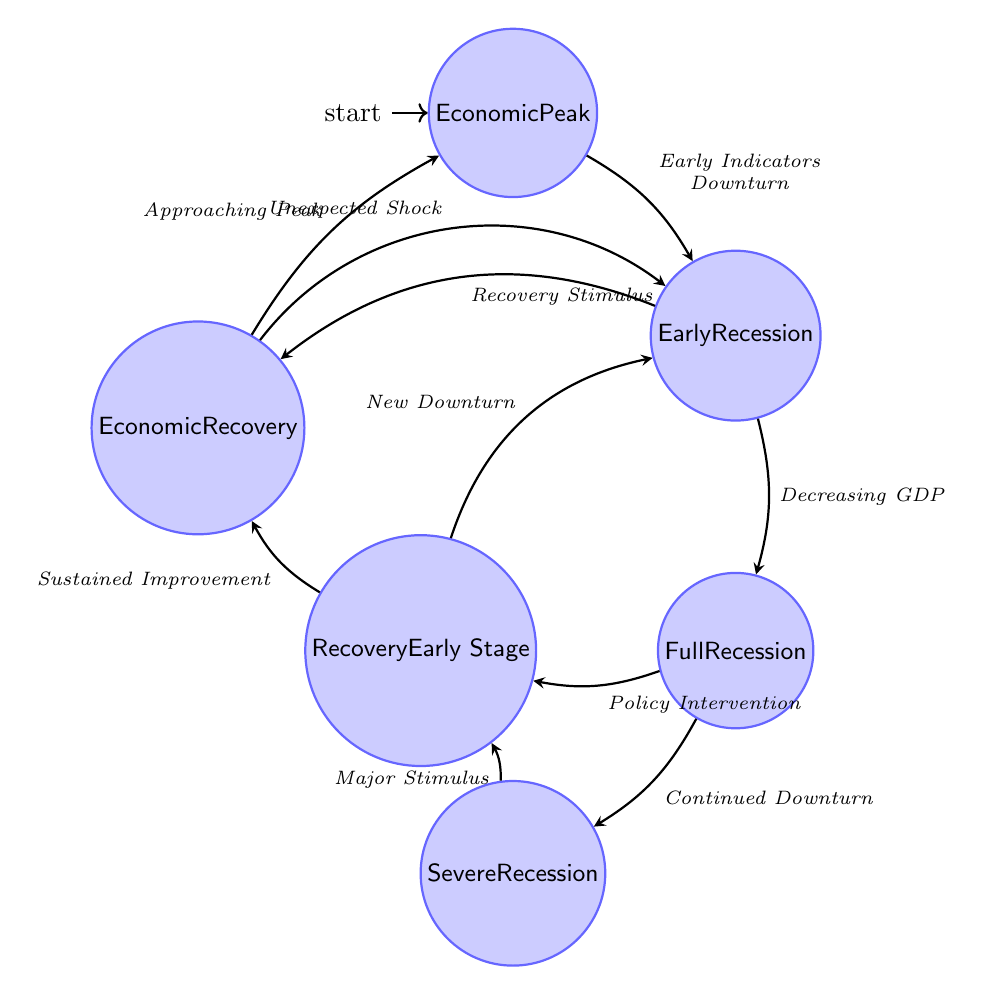What is the initial state of the diagram? The initial state is indicated as the starting point in the diagram, which is marked with an 'initial' symbol. Here, the node labeled "Economic Peak" represents the starting point of the Finite State Machine.
Answer: Economic Peak How many states are in the diagram? To find the total number of states, we count each distinct labeled state node in the diagram. There are six labeled states: Economic Peak, Early Recession, Full Recession, Severe Recession, Recovery Early Stage, and Economic Recovery.
Answer: 6 What transition leads to Severe Recession from Full Recession? The transition from Full Recession to Severe Recession is indicated by an arrow connecting the two states, labeled as "Continued Downturn."
Answer: Continued Downturn What event can transition from Early Recession to Economic Recovery? The event that enables this transition is "Recovery Stimulus," denoting a positive action taken during the Early Recession phase that can lead directly to Economic Recovery.
Answer: Recovery Stimulus In which state does the diagram indicate a possibility of returning to Early Recession? There are two possible transitions to Early Recession. One is from Recovery Early Stage labeled "New Downturn," and the other is from Economic Recovery labeled "Unexpected Shock."
Answer: New Downturn and Unexpected Shock Which state indicates a sustained period of negative GDP growth? The state characterized by sustained negative GDP growth, high unemployment, and lacks consumer and business confidence is labeled "Full Recession." This state is explicitly defined by those features.
Answer: Full Recession What is the last state that can lead back to Economic Peak? The transition back to Economic Peak happens during the Economic Recovery phase when the economy shows significant positive growth by transitioning through the event termed "Approaching Peak."
Answer: Economic Recovery What action is needed to move from Severe Recession to Recovery Early Stage? A significant intervention denoted by the event labeled "Major Stimulus" is necessary for transitioning from Severe Recession to the Recovery Early Stage phase.
Answer: Major Stimulus 